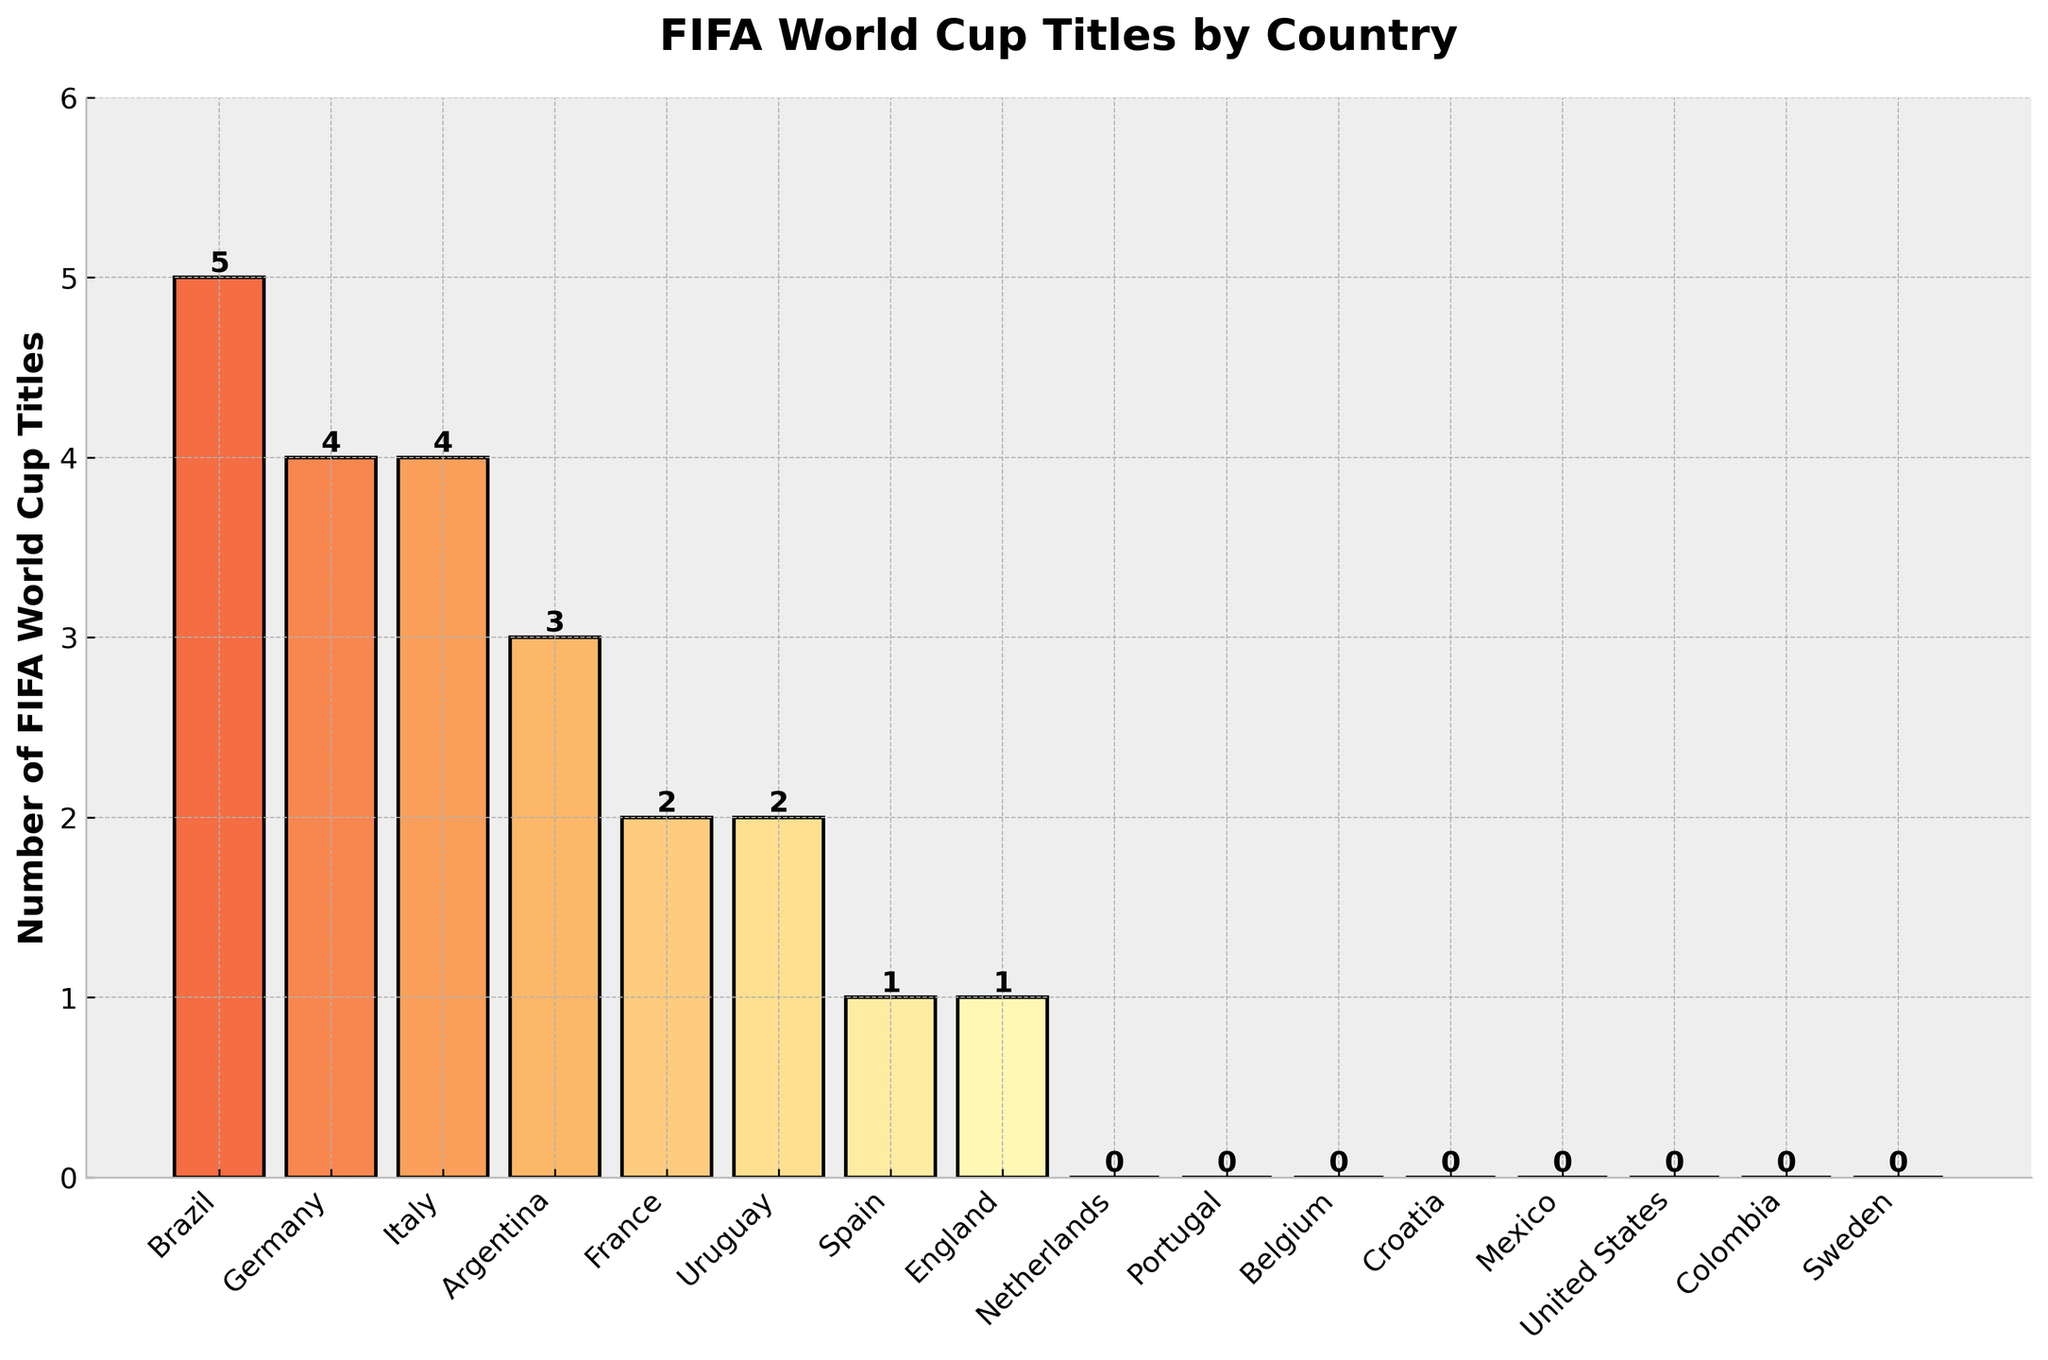Which country has won the most FIFA World Cup titles? To determine the country with the most titles, look for the highest bar in the figure. Brazil's bar is the highest.
Answer: Brazil How many countries have won exactly two FIFA World Cup titles? Count the bars with a height of 2. Both France and Uruguay have bars with a height of 2.
Answer: 2 What’s the total number of FIFA World Cup titles won by Argentina and England combined? Add the heights of the bars for Argentina (3) and England (1), so 3 + 1 = 4.
Answer: 4 Which countries have not won any FIFA World Cup titles? Find the bars with a height of 0. The bars for Netherlands, Portugal, Belgium, Croatia, Mexico, United States, Colombia, and Sweden have a height of 0.
Answer: Netherlands, Portugal, Belgium, Croatia, Mexico, United States, Colombia, Sweden Which country has won more FIFA World Cup titles, Italy or Germany? Compare the heights of Italy's bar (4) and Germany's bar (4). Both are equal.
Answer: Equal What’s the difference in the number of titles won by Brazil and Uruguay? Subtract the height of Uruguay's bar (2) from Brazil's bar (5), so 5 - 2 = 3.
Answer: 3 How many more World Cup titles has Brazil won compared to France? Brazil's bar is at 5 and France's bar is at 2, so 5 - 2 = 3.
Answer: 3 Which country has the second-highest number of FIFA World Cup titles? Identify the country with the bar that is the second tallest after Brazil. Both Germany and Italy have bars of 4, indicating the second-highest number of titles.
Answer: Germany, Italy How many countries have won at least one FIFA World Cup title? Count the bars with a height of 1 or more. Brazil, Germany, Italy, Argentina, France, Uruguay, Spain, and England have won at least one title. There are 8 such countries.
Answer: 8 What’s the total number of FIFA World Cup titles won by all countries combined? Sum the heights of all the bars: 5 + 4 + 4 + 3 + 2 + 2 + 1 + 1 = 22.
Answer: 22 